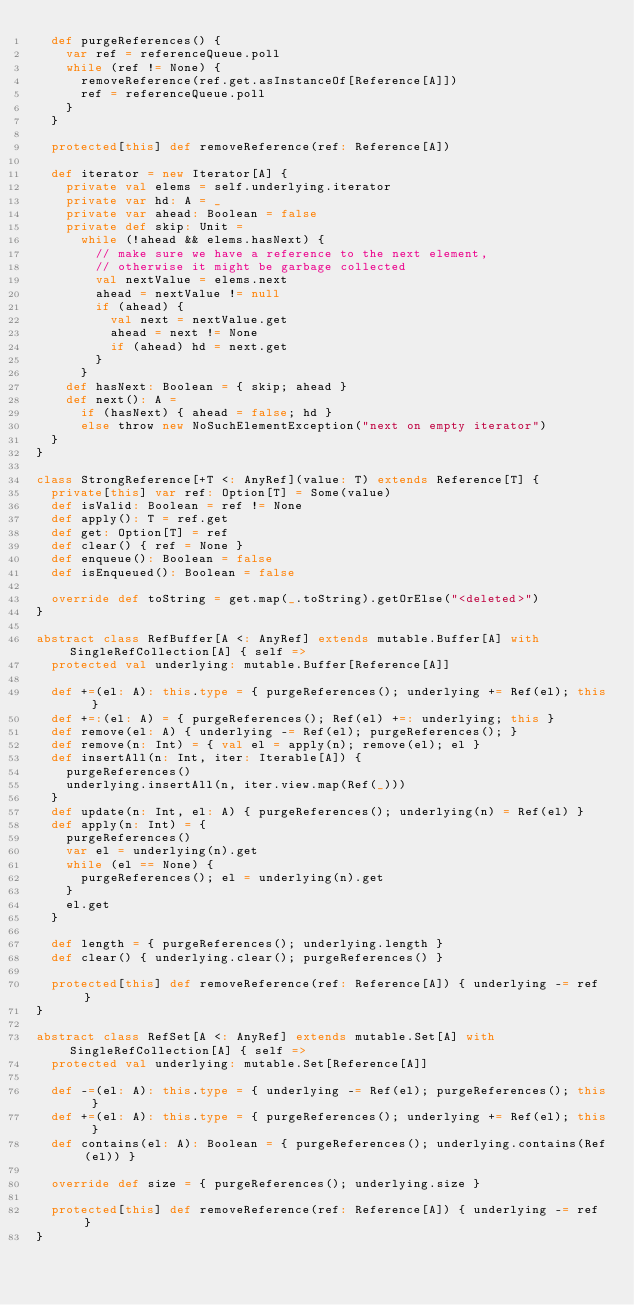Convert code to text. <code><loc_0><loc_0><loc_500><loc_500><_Scala_>  def purgeReferences() {
    var ref = referenceQueue.poll
    while (ref != None) {
      removeReference(ref.get.asInstanceOf[Reference[A]])
      ref = referenceQueue.poll
    }
  }

  protected[this] def removeReference(ref: Reference[A])

  def iterator = new Iterator[A] {
    private val elems = self.underlying.iterator
    private var hd: A = _
    private var ahead: Boolean = false
    private def skip: Unit =
      while (!ahead && elems.hasNext) {
        // make sure we have a reference to the next element,
        // otherwise it might be garbage collected
        val nextValue = elems.next
        ahead = nextValue != null
        if (ahead) {
          val next = nextValue.get
          ahead = next != None
          if (ahead) hd = next.get
        }
      }
    def hasNext: Boolean = { skip; ahead }
    def next(): A =
      if (hasNext) { ahead = false; hd }
      else throw new NoSuchElementException("next on empty iterator")
  }
}

class StrongReference[+T <: AnyRef](value: T) extends Reference[T] {
  private[this] var ref: Option[T] = Some(value)
  def isValid: Boolean = ref != None
  def apply(): T = ref.get
  def get: Option[T] = ref
  def clear() { ref = None }
  def enqueue(): Boolean = false
  def isEnqueued(): Boolean = false

  override def toString = get.map(_.toString).getOrElse("<deleted>")
}

abstract class RefBuffer[A <: AnyRef] extends mutable.Buffer[A] with SingleRefCollection[A] { self =>
  protected val underlying: mutable.Buffer[Reference[A]]

  def +=(el: A): this.type = { purgeReferences(); underlying += Ref(el); this }
  def +=:(el: A) = { purgeReferences(); Ref(el) +=: underlying; this }
  def remove(el: A) { underlying -= Ref(el); purgeReferences(); }
  def remove(n: Int) = { val el = apply(n); remove(el); el }
  def insertAll(n: Int, iter: Iterable[A]) {
    purgeReferences()
    underlying.insertAll(n, iter.view.map(Ref(_)))
  }
  def update(n: Int, el: A) { purgeReferences(); underlying(n) = Ref(el) }
  def apply(n: Int) = {
    purgeReferences()
    var el = underlying(n).get
    while (el == None) {
      purgeReferences(); el = underlying(n).get
    }
    el.get
  }

  def length = { purgeReferences(); underlying.length }
  def clear() { underlying.clear(); purgeReferences() }

  protected[this] def removeReference(ref: Reference[A]) { underlying -= ref }
}

abstract class RefSet[A <: AnyRef] extends mutable.Set[A] with SingleRefCollection[A] { self =>
  protected val underlying: mutable.Set[Reference[A]]

  def -=(el: A): this.type = { underlying -= Ref(el); purgeReferences(); this }
  def +=(el: A): this.type = { purgeReferences(); underlying += Ref(el); this }
  def contains(el: A): Boolean = { purgeReferences(); underlying.contains(Ref(el)) }

  override def size = { purgeReferences(); underlying.size }

  protected[this] def removeReference(ref: Reference[A]) { underlying -= ref }
}

</code> 